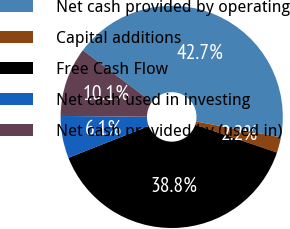<chart> <loc_0><loc_0><loc_500><loc_500><pie_chart><fcel>Net cash provided by operating<fcel>Capital additions<fcel>Free Cash Flow<fcel>Net cash used in investing<fcel>Net cash provided by (used in)<nl><fcel>42.7%<fcel>2.25%<fcel>38.82%<fcel>6.13%<fcel>10.11%<nl></chart> 